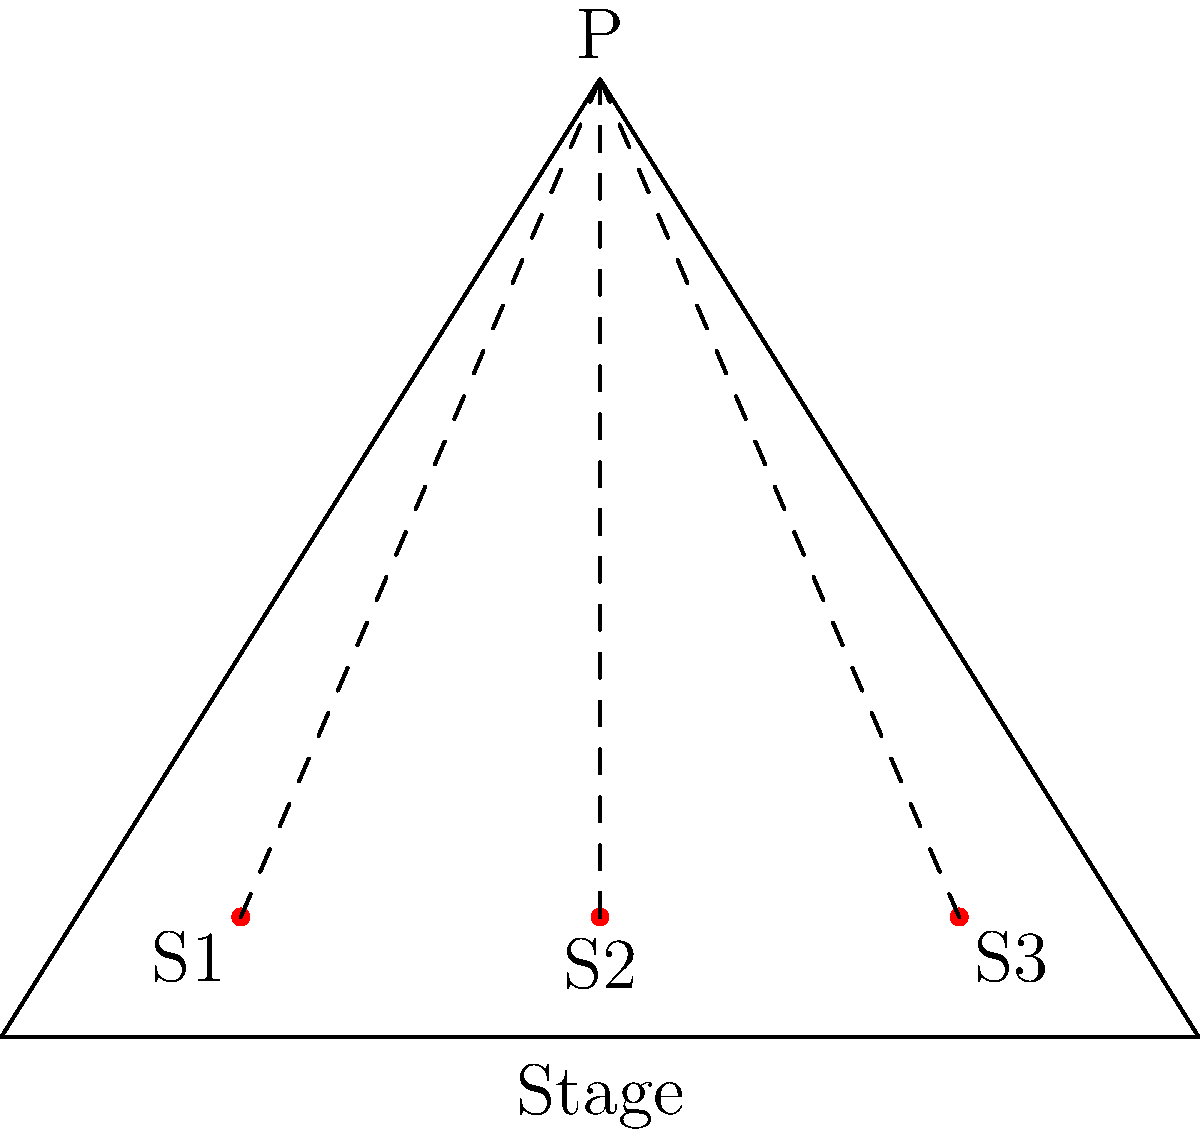In the theater layout shown, point P represents a performer on stage, and S1, S2, and S3 represent different seating positions. If the stage width (AB) is 50 feet and the distance from the stage to point P is 40 feet, what is the difference between the viewing angles of S1 and S3 in degrees? To solve this problem, we'll follow these steps:

1) First, we need to calculate the coordinates of points A, B, and P in a coordinate system where A is at (0,0) and B is at (50,0).
   A = (0,0)
   B = (50,0)
   P = (25,40) (since P is centered above the stage)

2) Next, we'll calculate the coordinates of S1 and S3. Let's assume they're 5 feet from the stage:
   S1 = (10,5)
   S3 = (40,5)

3) Now we can calculate the vectors from S1 and S3 to P:
   $\vec{S1P} = (25-10, 40-5) = (15, 35)$
   $\vec{S3P} = (25-40, 40-5) = (-15, 35)$

4) To find the viewing angles, we need to calculate the angles between these vectors and the positive x-axis:
   
   For S1: $\theta_1 = \arctan(\frac{35}{15}) \approx 66.80°$
   For S3: $\theta_3 = \arctan(\frac{35}{-15}) + 180° \approx 113.20°$

5) The difference between these angles is:
   $113.20° - 66.80° = 46.40°$

Therefore, the difference between the viewing angles of S1 and S3 is approximately 46.40°.
Answer: 46.40° 